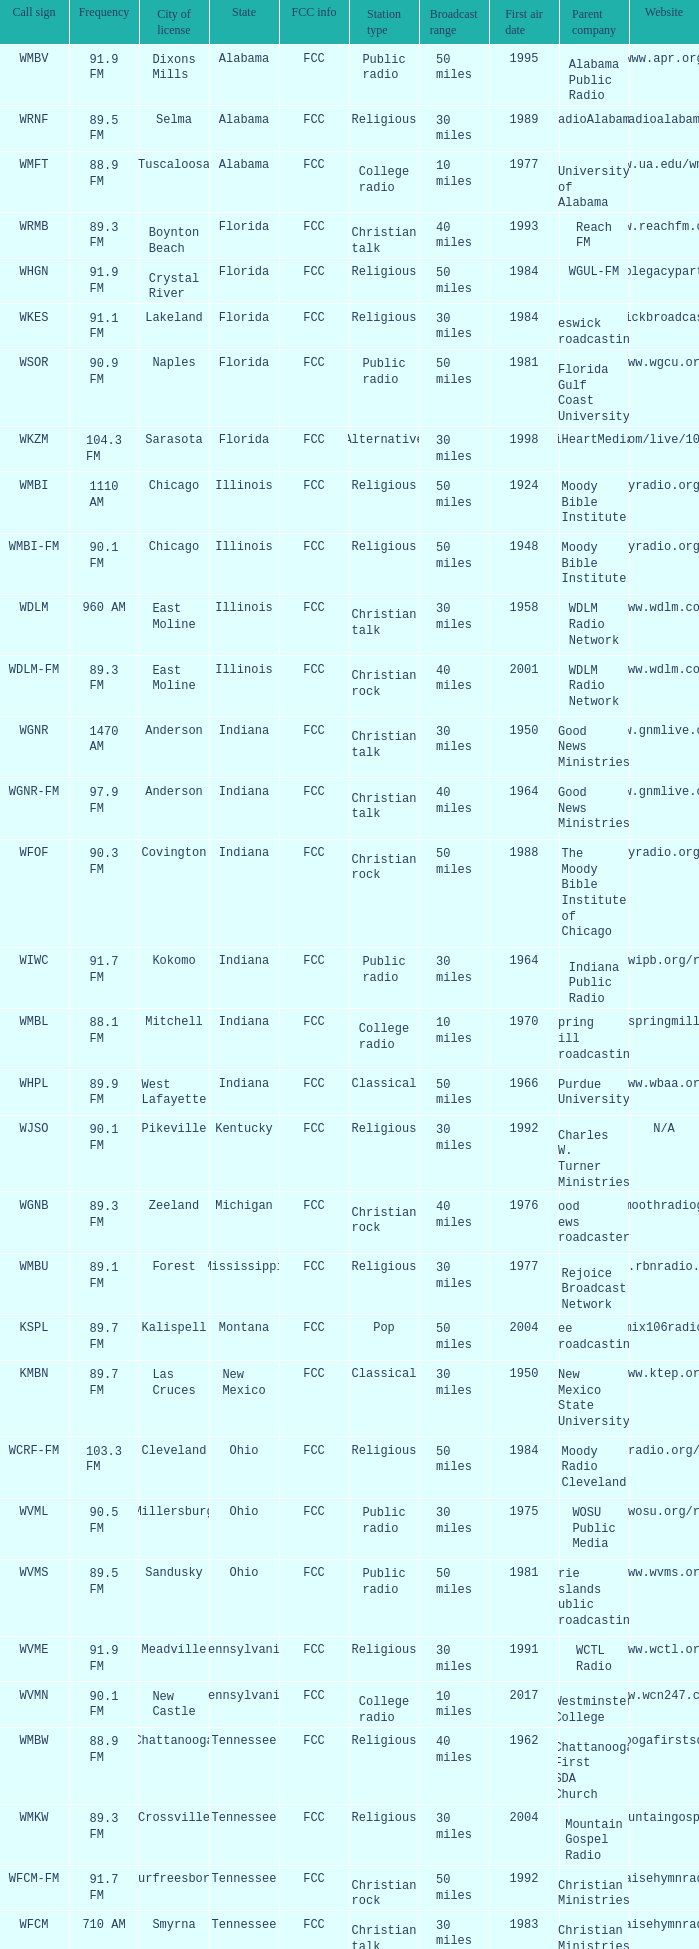1 fm frequency and a city license in new castle? Pennsylvania. 